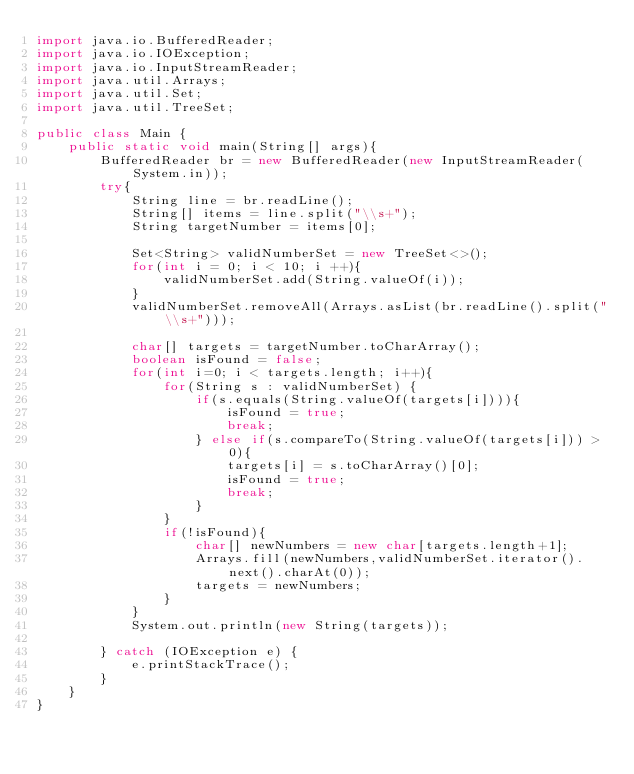<code> <loc_0><loc_0><loc_500><loc_500><_Java_>import java.io.BufferedReader;
import java.io.IOException;
import java.io.InputStreamReader;
import java.util.Arrays;
import java.util.Set;
import java.util.TreeSet;

public class Main {
    public static void main(String[] args){
        BufferedReader br = new BufferedReader(new InputStreamReader(System.in));
        try{
            String line = br.readLine();
            String[] items = line.split("\\s+");
            String targetNumber = items[0];

            Set<String> validNumberSet = new TreeSet<>();
            for(int i = 0; i < 10; i ++){
                validNumberSet.add(String.valueOf(i));
            }
            validNumberSet.removeAll(Arrays.asList(br.readLine().split("\\s+")));

            char[] targets = targetNumber.toCharArray();
            boolean isFound = false;
            for(int i=0; i < targets.length; i++){
                for(String s : validNumberSet) {
                    if(s.equals(String.valueOf(targets[i]))){
                        isFound = true;
                        break;
                    } else if(s.compareTo(String.valueOf(targets[i])) > 0){
                        targets[i] = s.toCharArray()[0];
                        isFound = true;
                        break;
                    }
                }
                if(!isFound){
                    char[] newNumbers = new char[targets.length+1];
                    Arrays.fill(newNumbers,validNumberSet.iterator().next().charAt(0));
                    targets = newNumbers;
                }
            }
            System.out.println(new String(targets));

        } catch (IOException e) {
            e.printStackTrace();
        }
    }
}
</code> 